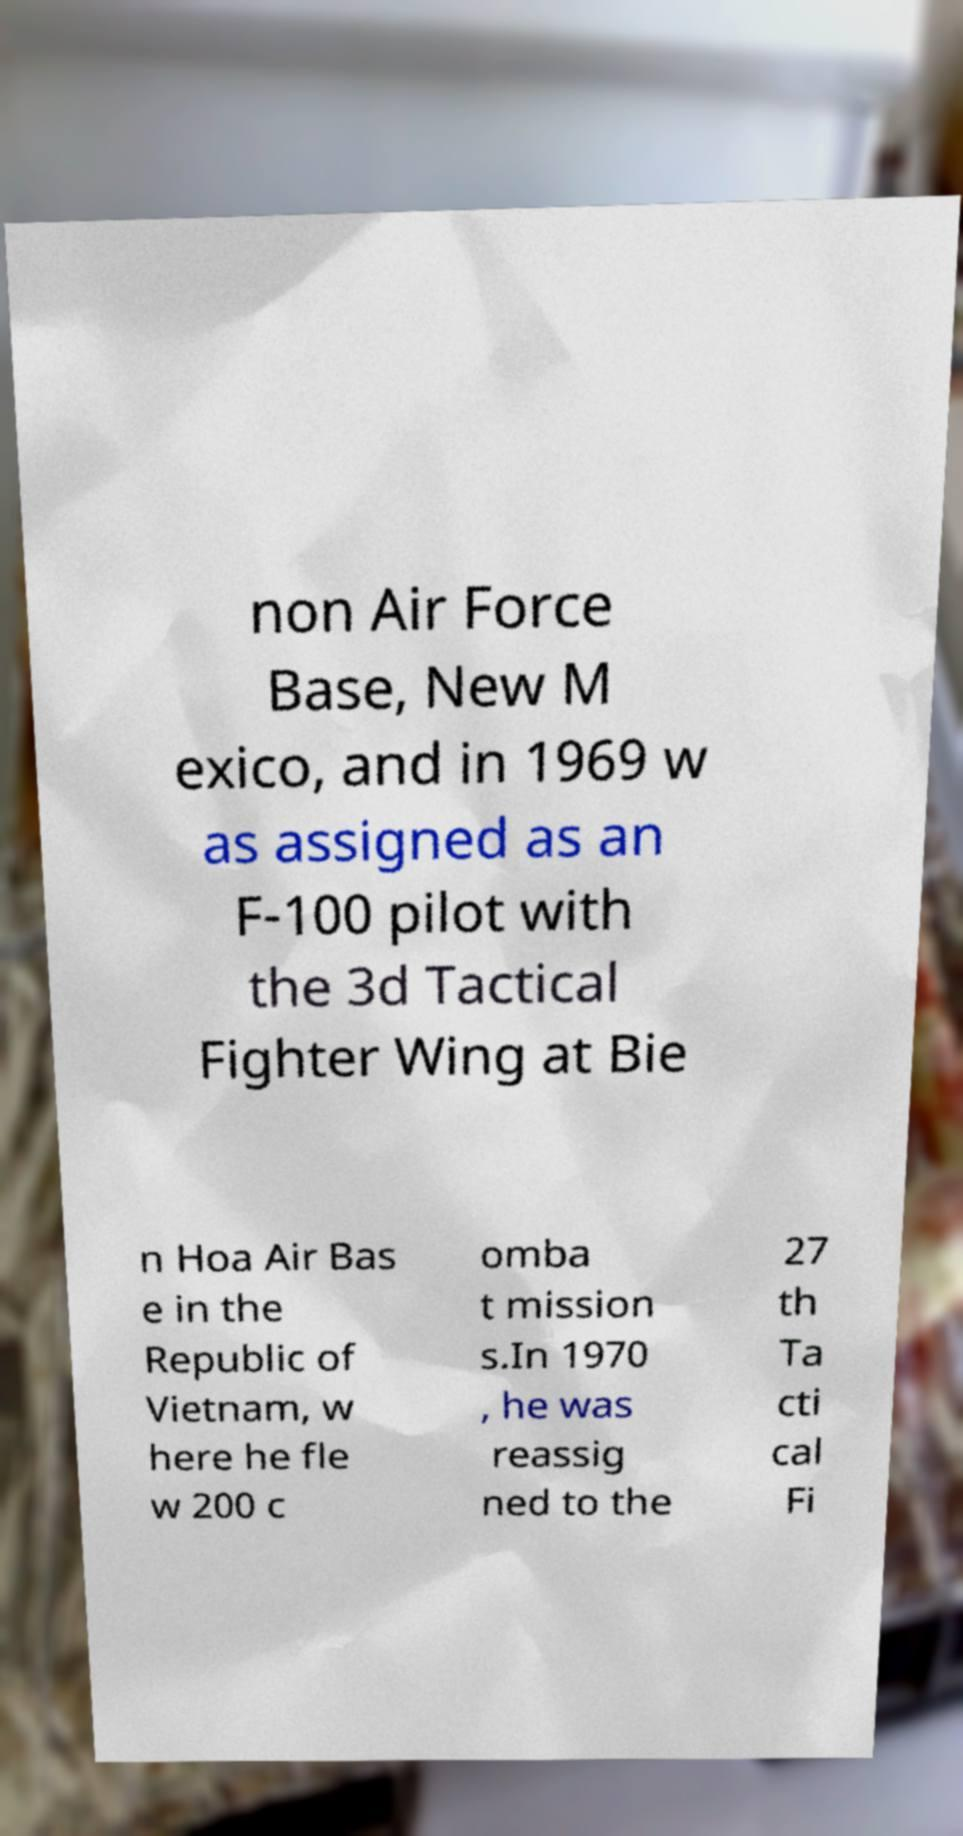Could you extract and type out the text from this image? non Air Force Base, New M exico, and in 1969 w as assigned as an F-100 pilot with the 3d Tactical Fighter Wing at Bie n Hoa Air Bas e in the Republic of Vietnam, w here he fle w 200 c omba t mission s.In 1970 , he was reassig ned to the 27 th Ta cti cal Fi 